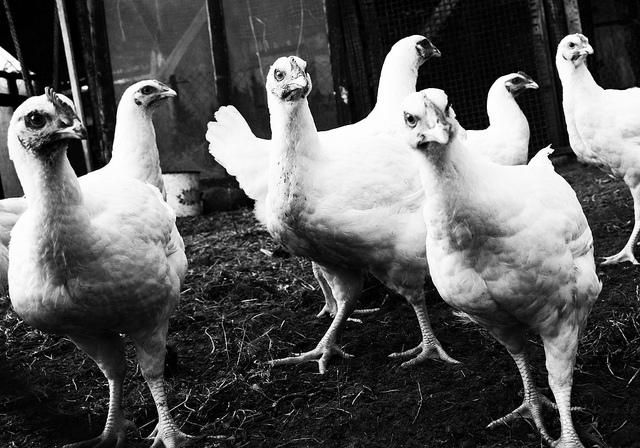What type of animal is in the image? Please explain your reasoning. chickens. The animal is a chicken. 